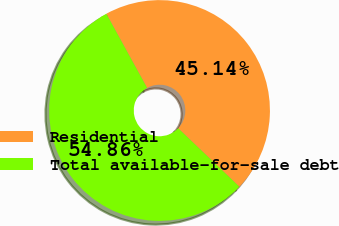Convert chart to OTSL. <chart><loc_0><loc_0><loc_500><loc_500><pie_chart><fcel>Residential<fcel>Total available-for-sale debt<nl><fcel>45.14%<fcel>54.86%<nl></chart> 